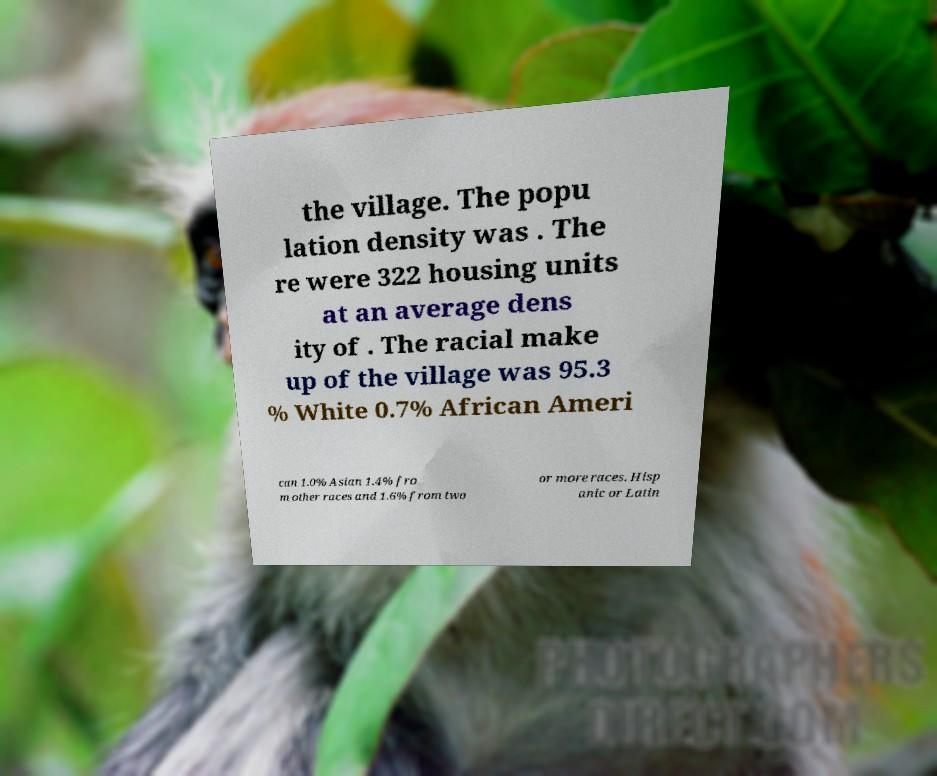For documentation purposes, I need the text within this image transcribed. Could you provide that? the village. The popu lation density was . The re were 322 housing units at an average dens ity of . The racial make up of the village was 95.3 % White 0.7% African Ameri can 1.0% Asian 1.4% fro m other races and 1.6% from two or more races. Hisp anic or Latin 